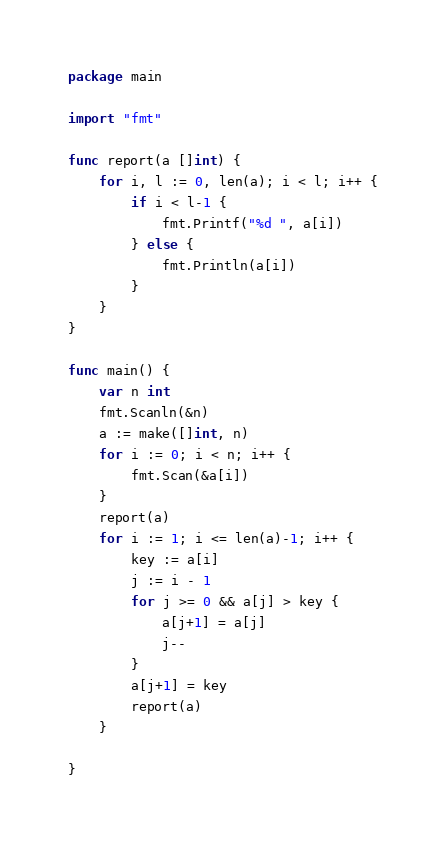<code> <loc_0><loc_0><loc_500><loc_500><_Go_>package main

import "fmt"

func report(a []int) {
	for i, l := 0, len(a); i < l; i++ {
		if i < l-1 {
			fmt.Printf("%d ", a[i])
		} else {
			fmt.Println(a[i])
		}
	}
}

func main() {
	var n int
	fmt.Scanln(&n)
	a := make([]int, n)
	for i := 0; i < n; i++ {
		fmt.Scan(&a[i])
	}
	report(a)
	for i := 1; i <= len(a)-1; i++ {
		key := a[i]
		j := i - 1
		for j >= 0 && a[j] > key {
			a[j+1] = a[j]
			j--
		}
		a[j+1] = key
		report(a)
	}

}
</code> 